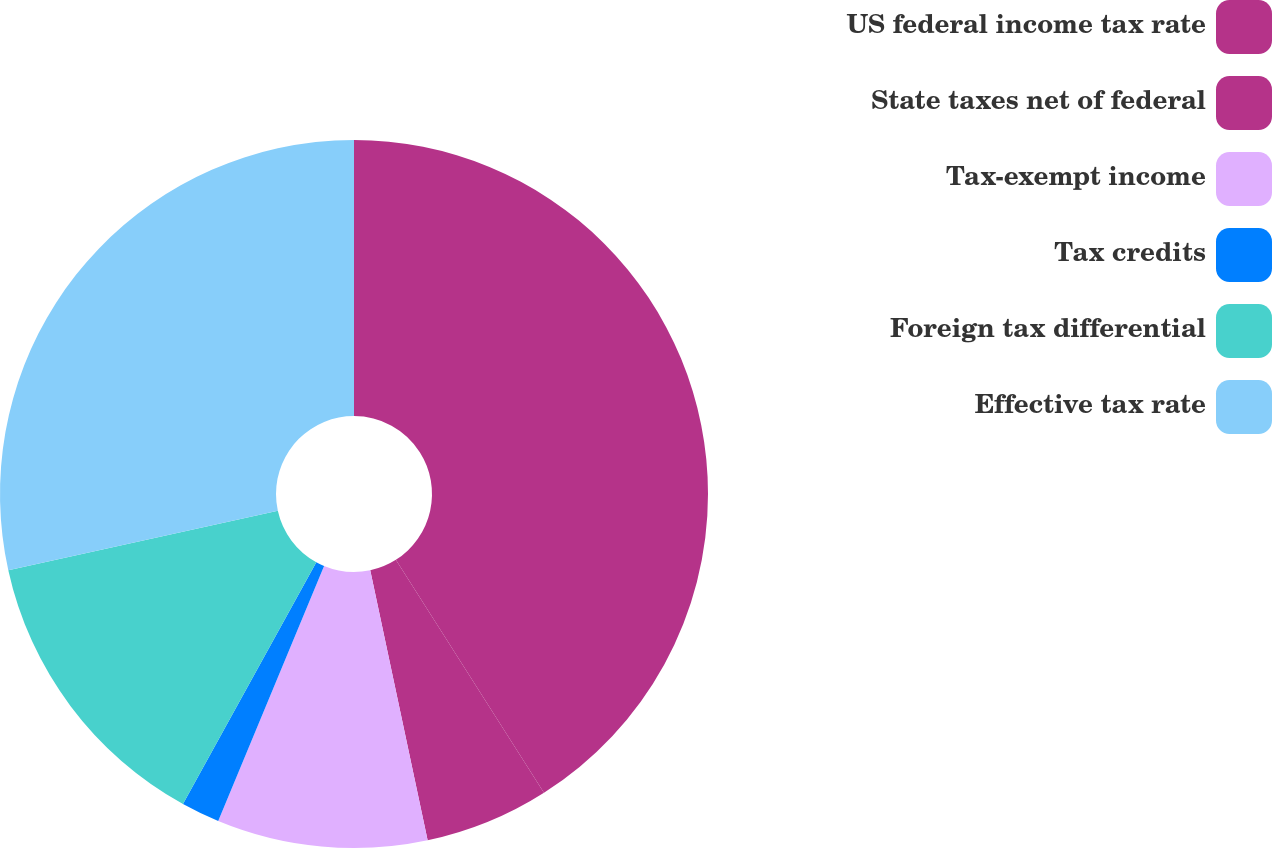<chart> <loc_0><loc_0><loc_500><loc_500><pie_chart><fcel>US federal income tax rate<fcel>State taxes net of federal<fcel>Tax-exempt income<fcel>Tax credits<fcel>Foreign tax differential<fcel>Effective tax rate<nl><fcel>40.98%<fcel>5.68%<fcel>9.6%<fcel>1.76%<fcel>13.52%<fcel>28.45%<nl></chart> 